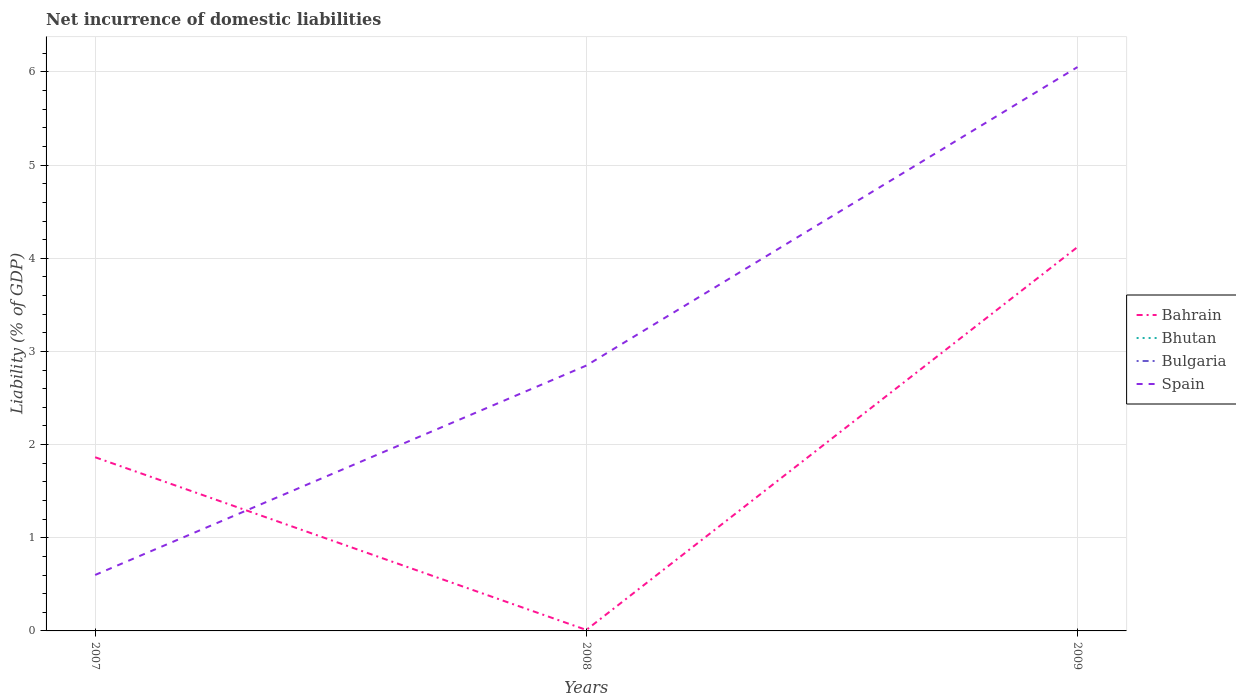How many different coloured lines are there?
Offer a very short reply. 2. Does the line corresponding to Bulgaria intersect with the line corresponding to Spain?
Offer a terse response. No. Is the number of lines equal to the number of legend labels?
Offer a very short reply. No. Across all years, what is the maximum net incurrence of domestic liabilities in Bulgaria?
Provide a short and direct response. 0. What is the total net incurrence of domestic liabilities in Bahrain in the graph?
Your response must be concise. -2.26. What is the difference between the highest and the second highest net incurrence of domestic liabilities in Bahrain?
Keep it short and to the point. 4.11. Is the net incurrence of domestic liabilities in Spain strictly greater than the net incurrence of domestic liabilities in Bulgaria over the years?
Your answer should be very brief. No. How many years are there in the graph?
Keep it short and to the point. 3. What is the difference between two consecutive major ticks on the Y-axis?
Your answer should be very brief. 1. Does the graph contain any zero values?
Offer a terse response. Yes. How many legend labels are there?
Give a very brief answer. 4. How are the legend labels stacked?
Your answer should be very brief. Vertical. What is the title of the graph?
Keep it short and to the point. Net incurrence of domestic liabilities. What is the label or title of the Y-axis?
Your answer should be very brief. Liability (% of GDP). What is the Liability (% of GDP) of Bahrain in 2007?
Make the answer very short. 1.86. What is the Liability (% of GDP) in Bulgaria in 2007?
Make the answer very short. 0. What is the Liability (% of GDP) of Spain in 2007?
Your answer should be very brief. 0.6. What is the Liability (% of GDP) of Bahrain in 2008?
Provide a short and direct response. 0.01. What is the Liability (% of GDP) of Bhutan in 2008?
Offer a very short reply. 0. What is the Liability (% of GDP) of Bulgaria in 2008?
Give a very brief answer. 0. What is the Liability (% of GDP) in Spain in 2008?
Ensure brevity in your answer.  2.85. What is the Liability (% of GDP) in Bahrain in 2009?
Keep it short and to the point. 4.12. What is the Liability (% of GDP) of Bhutan in 2009?
Keep it short and to the point. 0. What is the Liability (% of GDP) in Spain in 2009?
Keep it short and to the point. 6.05. Across all years, what is the maximum Liability (% of GDP) of Bahrain?
Ensure brevity in your answer.  4.12. Across all years, what is the maximum Liability (% of GDP) of Spain?
Keep it short and to the point. 6.05. Across all years, what is the minimum Liability (% of GDP) in Bahrain?
Your answer should be compact. 0.01. Across all years, what is the minimum Liability (% of GDP) of Spain?
Provide a short and direct response. 0.6. What is the total Liability (% of GDP) in Bahrain in the graph?
Provide a short and direct response. 6. What is the total Liability (% of GDP) of Bhutan in the graph?
Your answer should be compact. 0. What is the total Liability (% of GDP) of Spain in the graph?
Offer a very short reply. 9.5. What is the difference between the Liability (% of GDP) of Bahrain in 2007 and that in 2008?
Give a very brief answer. 1.85. What is the difference between the Liability (% of GDP) in Spain in 2007 and that in 2008?
Make the answer very short. -2.25. What is the difference between the Liability (% of GDP) of Bahrain in 2007 and that in 2009?
Offer a terse response. -2.26. What is the difference between the Liability (% of GDP) of Spain in 2007 and that in 2009?
Give a very brief answer. -5.45. What is the difference between the Liability (% of GDP) of Bahrain in 2008 and that in 2009?
Your answer should be compact. -4.11. What is the difference between the Liability (% of GDP) in Spain in 2008 and that in 2009?
Offer a very short reply. -3.2. What is the difference between the Liability (% of GDP) in Bahrain in 2007 and the Liability (% of GDP) in Spain in 2008?
Offer a very short reply. -0.98. What is the difference between the Liability (% of GDP) in Bahrain in 2007 and the Liability (% of GDP) in Spain in 2009?
Your answer should be compact. -4.19. What is the difference between the Liability (% of GDP) of Bahrain in 2008 and the Liability (% of GDP) of Spain in 2009?
Your answer should be very brief. -6.04. What is the average Liability (% of GDP) in Bahrain per year?
Make the answer very short. 2. What is the average Liability (% of GDP) in Bulgaria per year?
Offer a very short reply. 0. What is the average Liability (% of GDP) in Spain per year?
Ensure brevity in your answer.  3.17. In the year 2007, what is the difference between the Liability (% of GDP) in Bahrain and Liability (% of GDP) in Spain?
Offer a very short reply. 1.26. In the year 2008, what is the difference between the Liability (% of GDP) in Bahrain and Liability (% of GDP) in Spain?
Offer a terse response. -2.84. In the year 2009, what is the difference between the Liability (% of GDP) in Bahrain and Liability (% of GDP) in Spain?
Offer a terse response. -1.93. What is the ratio of the Liability (% of GDP) in Bahrain in 2007 to that in 2008?
Keep it short and to the point. 173.3. What is the ratio of the Liability (% of GDP) of Spain in 2007 to that in 2008?
Give a very brief answer. 0.21. What is the ratio of the Liability (% of GDP) in Bahrain in 2007 to that in 2009?
Keep it short and to the point. 0.45. What is the ratio of the Liability (% of GDP) of Spain in 2007 to that in 2009?
Provide a succinct answer. 0.1. What is the ratio of the Liability (% of GDP) of Bahrain in 2008 to that in 2009?
Provide a succinct answer. 0. What is the ratio of the Liability (% of GDP) of Spain in 2008 to that in 2009?
Provide a short and direct response. 0.47. What is the difference between the highest and the second highest Liability (% of GDP) of Bahrain?
Ensure brevity in your answer.  2.26. What is the difference between the highest and the second highest Liability (% of GDP) of Spain?
Provide a succinct answer. 3.2. What is the difference between the highest and the lowest Liability (% of GDP) in Bahrain?
Your answer should be compact. 4.11. What is the difference between the highest and the lowest Liability (% of GDP) of Spain?
Ensure brevity in your answer.  5.45. 